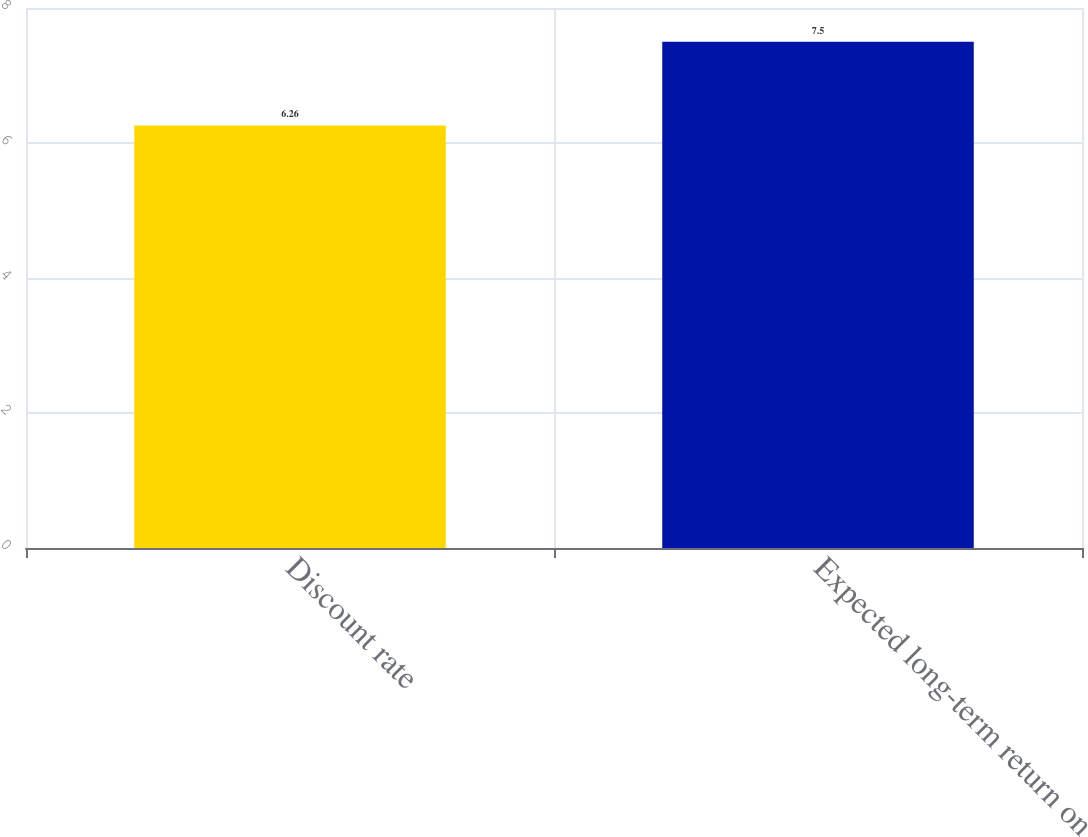Convert chart. <chart><loc_0><loc_0><loc_500><loc_500><bar_chart><fcel>Discount rate<fcel>Expected long-term return on<nl><fcel>6.26<fcel>7.5<nl></chart> 